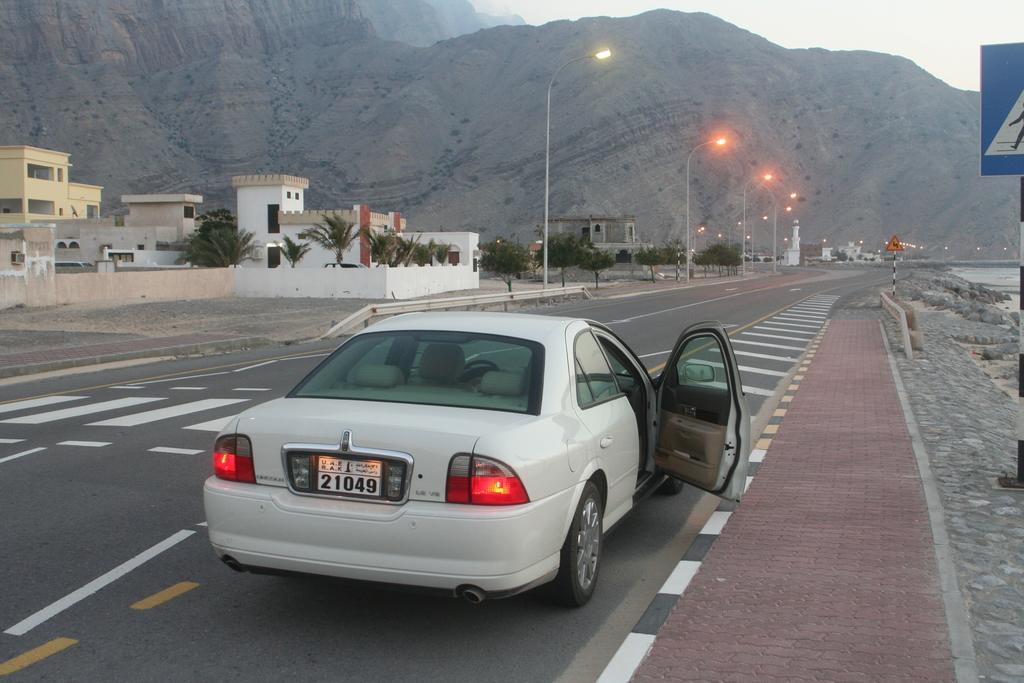Describe this image in one or two sentences. In this image I can see a road and on it I can see number of lines and a white colour car. On the right side of the image I can see two sign boards and on the left side I can see number of poles, street lights, number of trees and buildings. I can also see mountains in the background. 